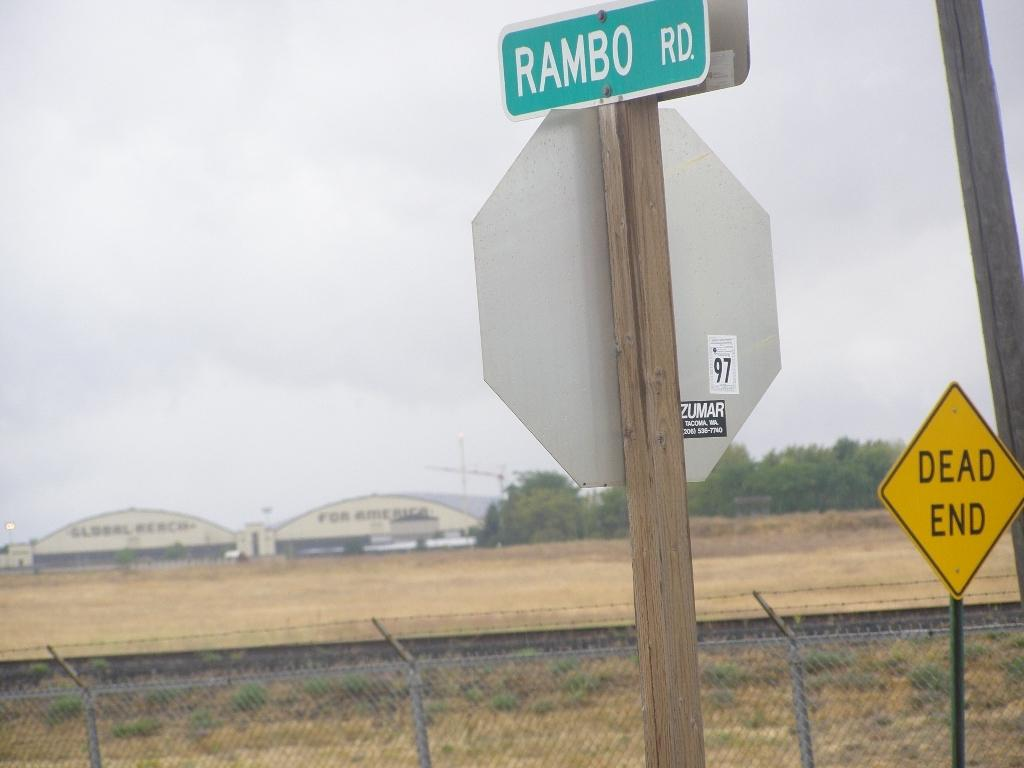<image>
Relay a brief, clear account of the picture shown. Green sign on a pole which says "Rambo" on it. 